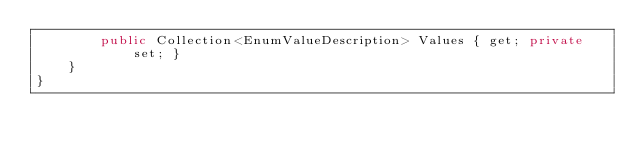<code> <loc_0><loc_0><loc_500><loc_500><_C#_>        public Collection<EnumValueDescription> Values { get; private set; }
    }
}</code> 